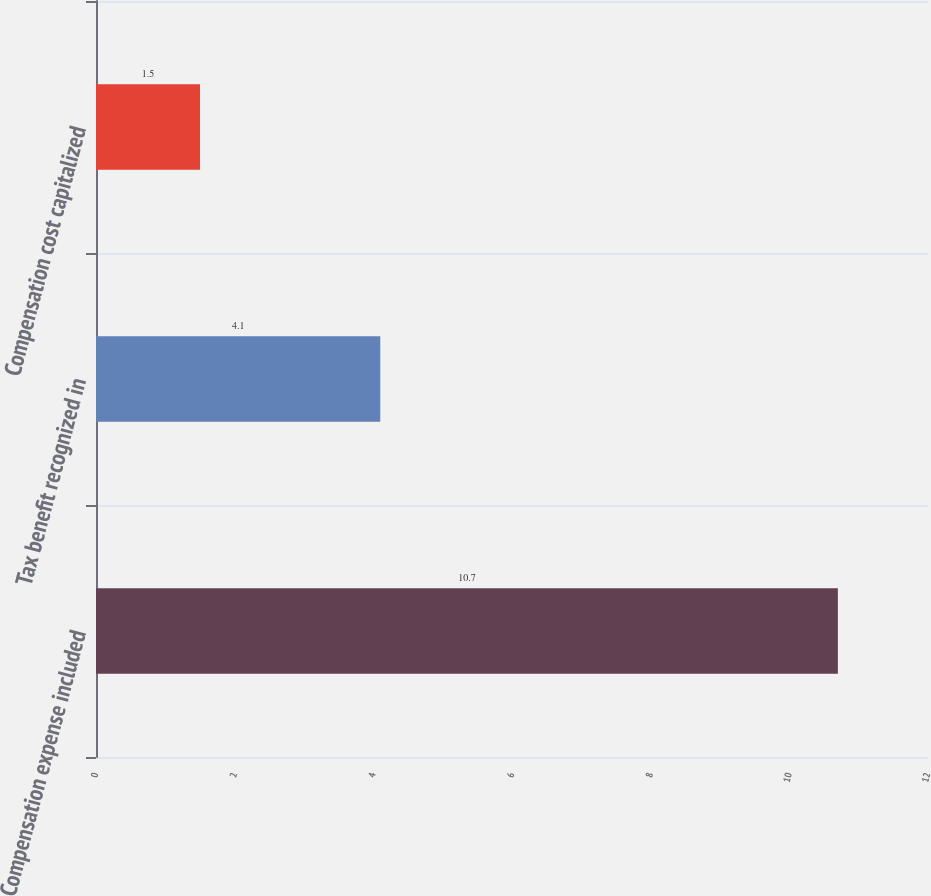Convert chart. <chart><loc_0><loc_0><loc_500><loc_500><bar_chart><fcel>Compensation expense included<fcel>Tax benefit recognized in<fcel>Compensation cost capitalized<nl><fcel>10.7<fcel>4.1<fcel>1.5<nl></chart> 